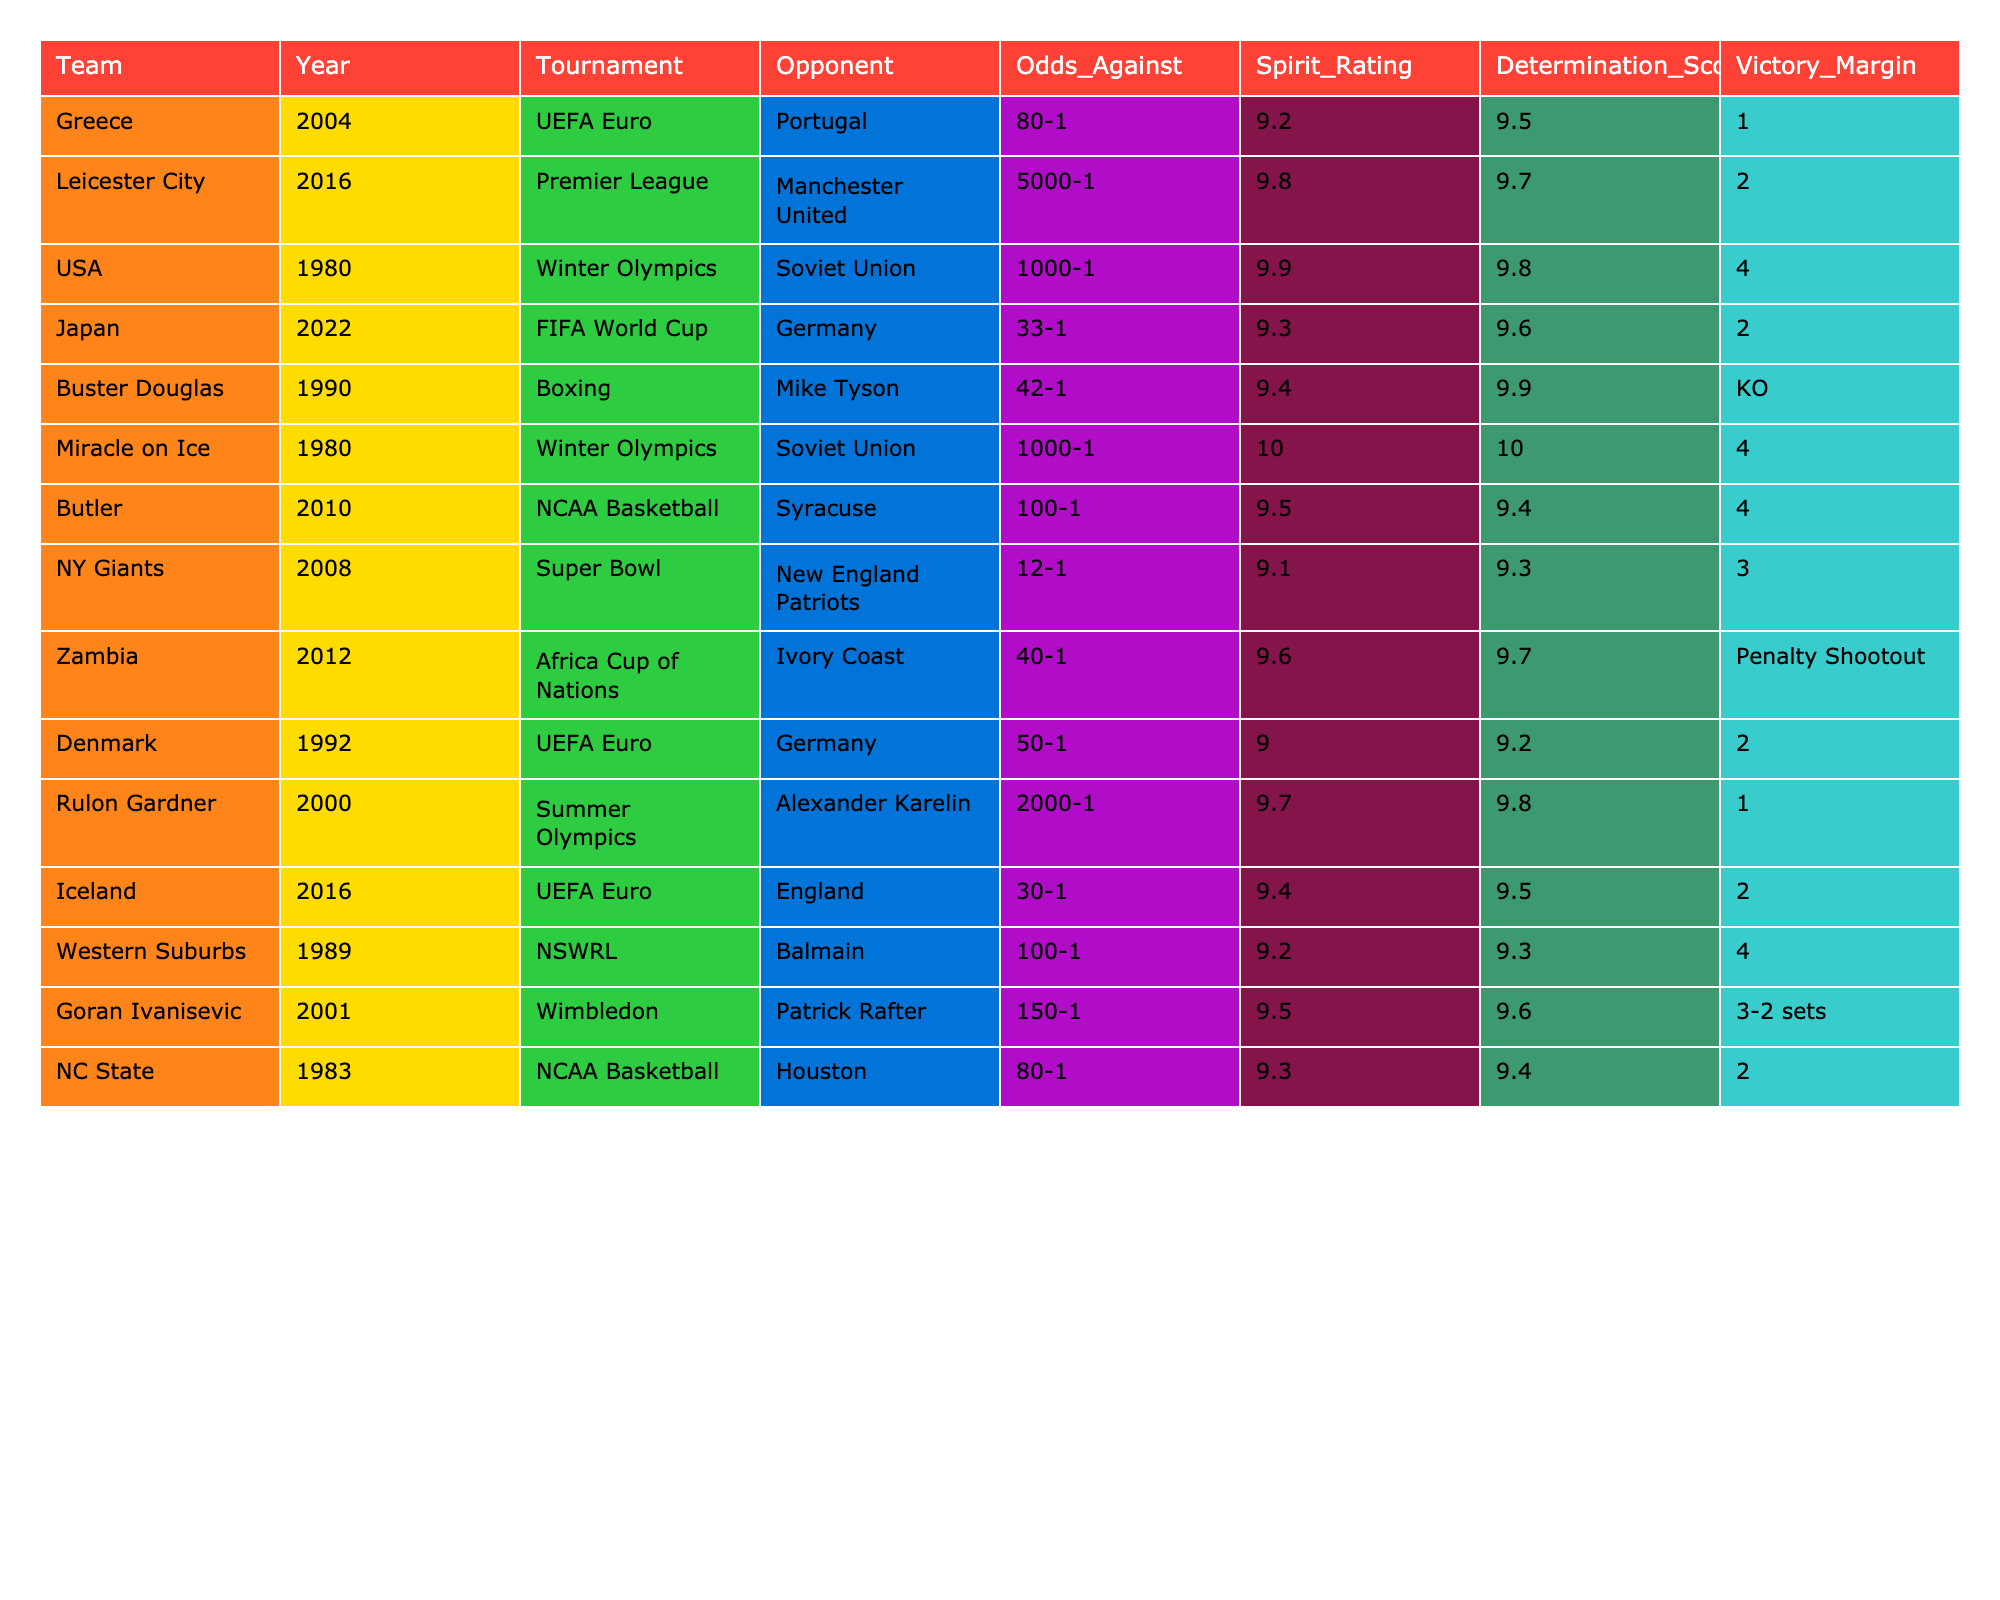What year did Greece achieve their underdog victory? From the table, Greece is listed under the year 2004 for their victory against Portugal.
Answer: 2004 Which team had the highest spirit rating? Checking the Spirit Ratings column, the USA in 1980 has the highest rating of 9.9, tied with Miracle on Ice of the same year.
Answer: 9.9 What was the victory margin for Leicester City in 2016? Referring to the Victory Margin column, Leicester City won with a margin of 2.
Answer: 2 Did any team win their match by penalty shootout? By looking at the Victory Margin column, Zambia in 2012 won by a penalty shootout, which implies they didn't have a defined margin like other victories.
Answer: Yes What is the average spirit rating of all the teams listed? Summing the Spirit Ratings (9.2+9.8+9.9+9.3+9.4+10+9.5+9.1+9.6+9.0+9.7+9.4+9.5) gives 123.4. Then, dividing by the number of teams (13) results in an average of approximately 9.52.
Answer: Approximately 9.52 How many teams had a Victory Margin of 2? Searching through the Victory Margin column, the teams with a margin of 2 are Japan, Denmark, and Leicester City, totaling 3 teams.
Answer: 3 Which win had the highest odds against? In the Odds Against column, Leicester City in 2016 had the highest odds against at 5000-1.
Answer: 5000-1 Which tournament had the most underdog victories listed? Analyzing the table, the Winter Olympics includes two entries: USA in 1980 and Miracle on Ice, thus it's the tournament with the most underdog victories.
Answer: Winter Olympics What was Rulon Gardner's victory margin against Alexander Karelin? The table indicates Rulon Gardner's victory margin is 1.
Answer: 1 Which team had a victory margin of 4? Looking at the Victory Margin column, the teams with a victory margin of 4 are the USA, Miracle on Ice, Butler, and Western Suburbs.
Answer: 4 Teams 